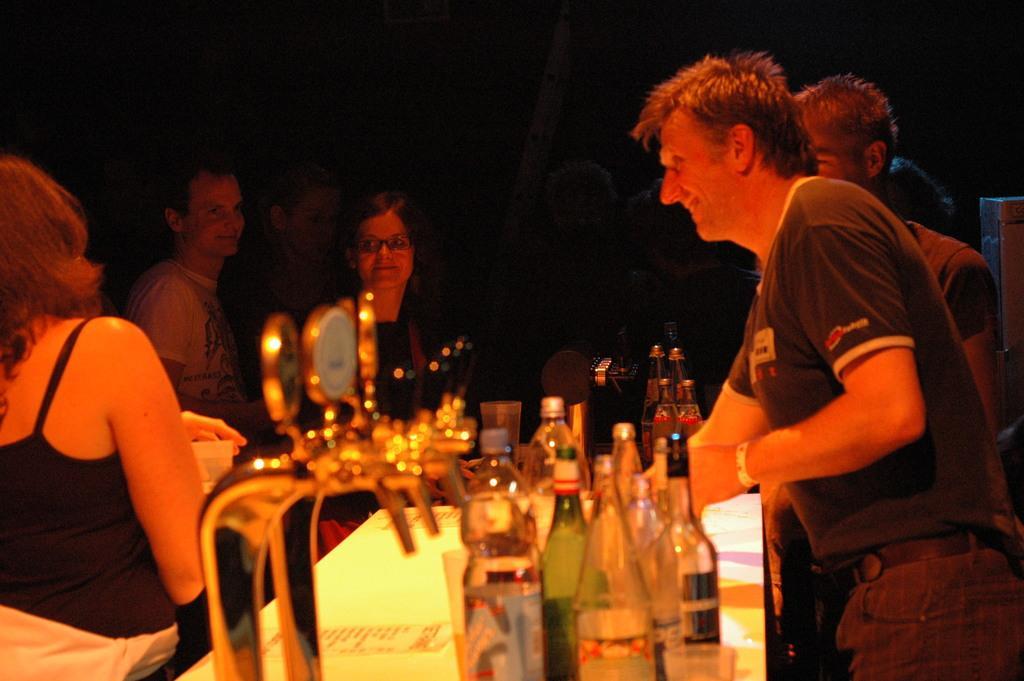Please provide a concise description of this image. There is a group of persons. They are standing. There is a table. There is a bottle on a table. On the left side of the woman is holding a cup. 